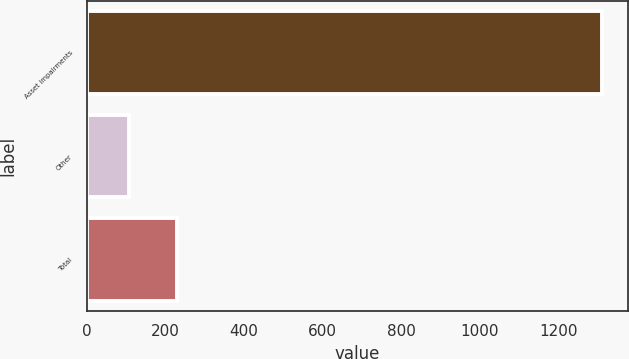Convert chart to OTSL. <chart><loc_0><loc_0><loc_500><loc_500><bar_chart><fcel>Asset impairments<fcel>Other<fcel>Total<nl><fcel>1310<fcel>108<fcel>228.2<nl></chart> 